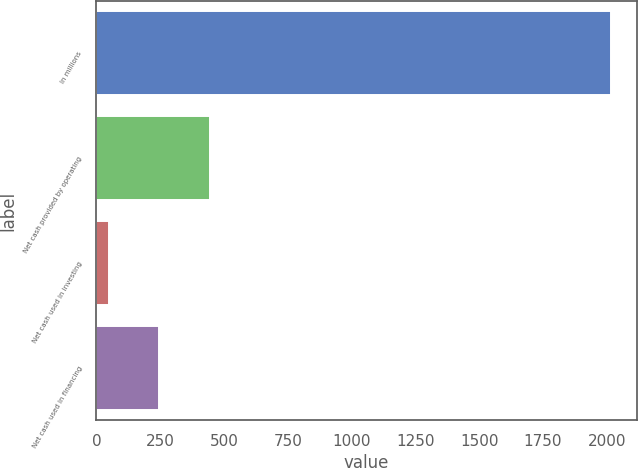<chart> <loc_0><loc_0><loc_500><loc_500><bar_chart><fcel>In millions<fcel>Net cash provided by operating<fcel>Net cash used in investing<fcel>Net cash used in financing<nl><fcel>2017<fcel>443.56<fcel>50.2<fcel>246.88<nl></chart> 